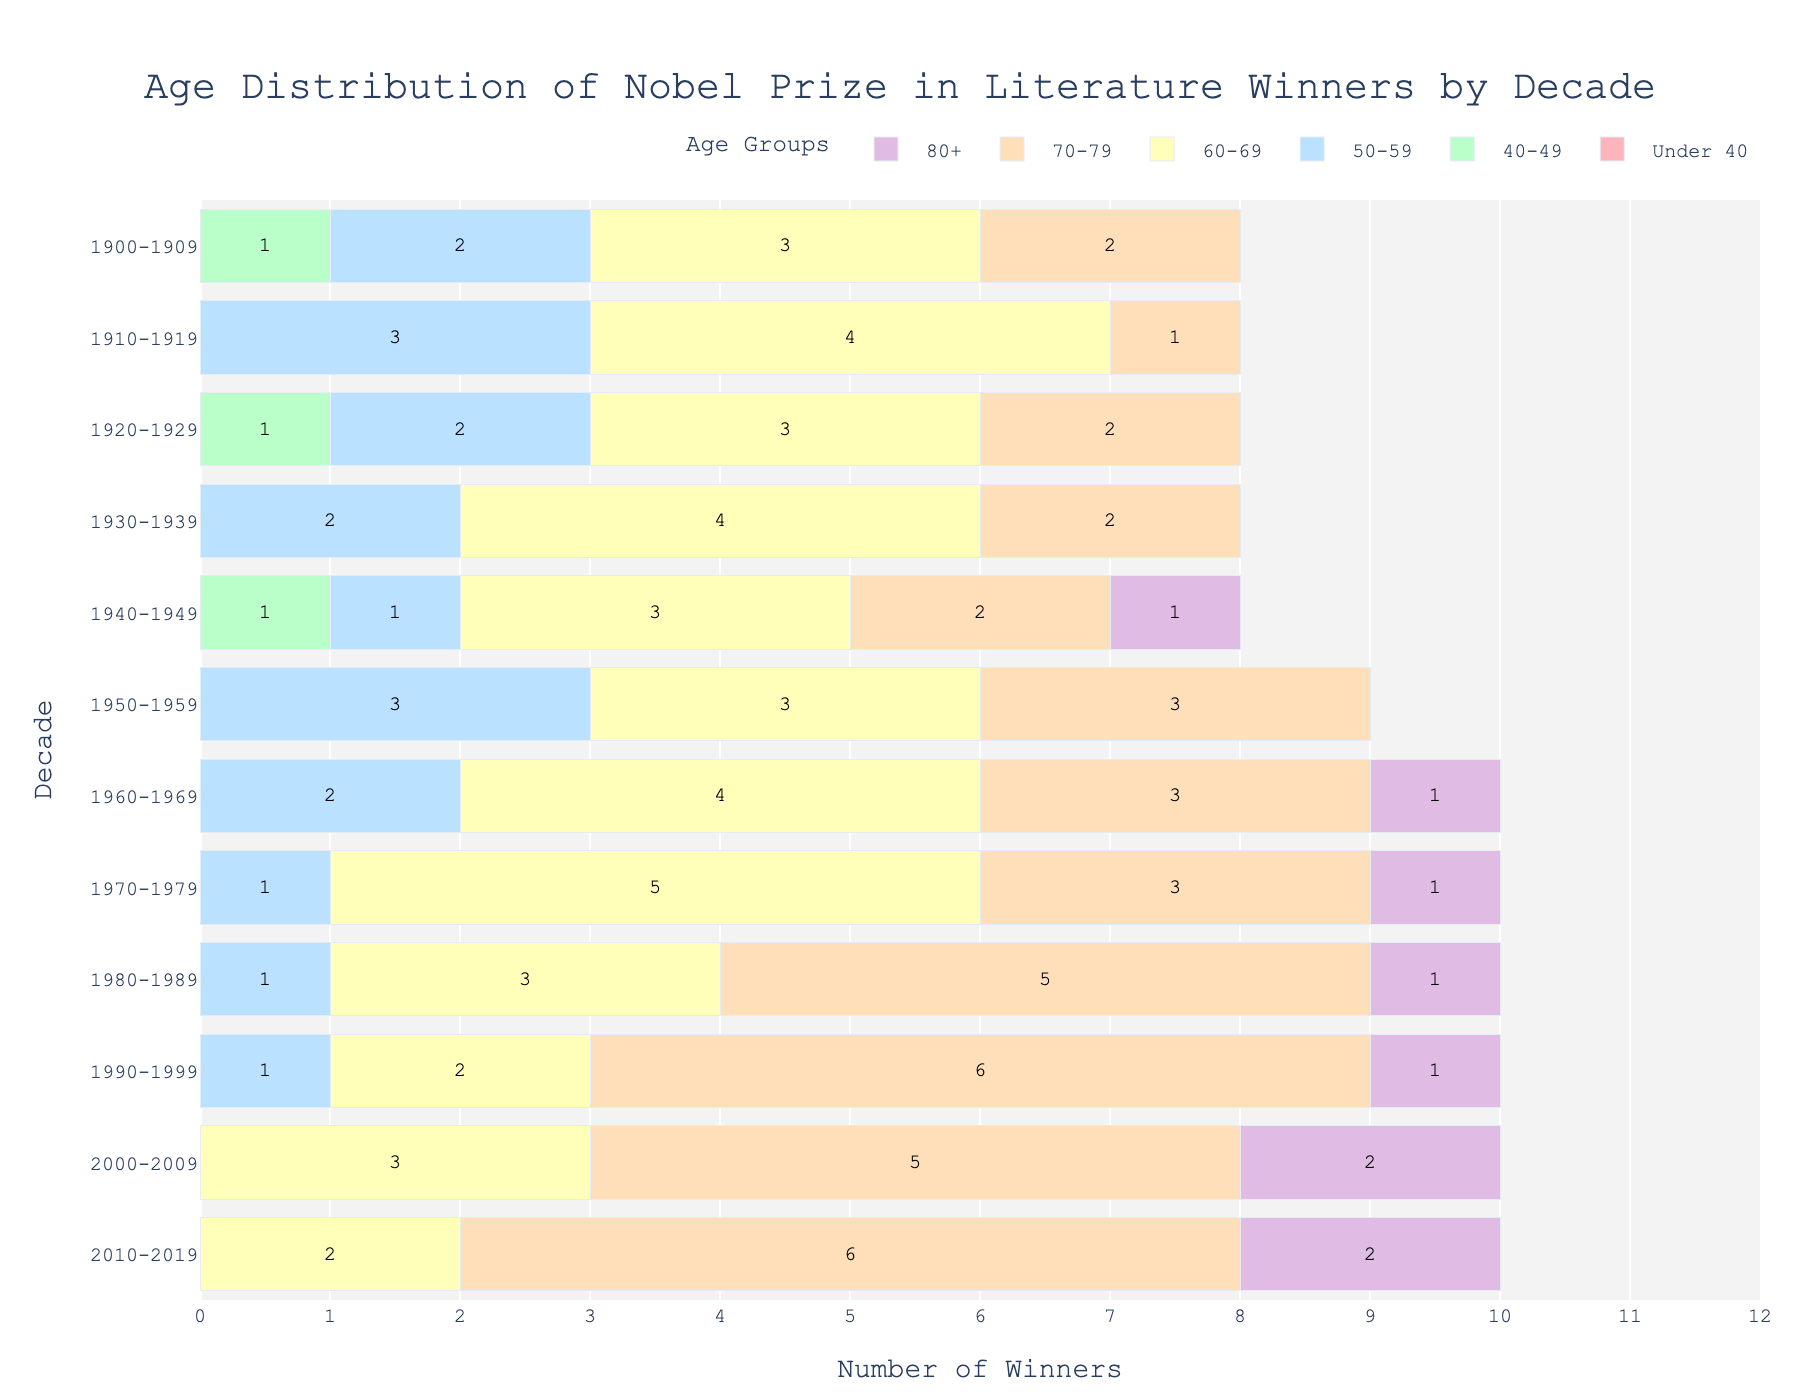How many age groups are represented in the population pyramid? There are six age groups represented in the figure. These are under 40, 40-49, 50-59, 60-69, 70-79, and 80+.
Answer: Six What is the title of the figure? The title of the figure is "Age Distribution of Nobel Prize in Literature Winners by Decade".
Answer: Age Distribution of Nobel Prize in Literature Winners by Decade In which decade did the highest number of winners aged 70-79 receive the Nobel Prize? Look at the bars colored in yellow (representing age 70-79) and find the one with the highest value. The decade is 1990-1999.
Answer: 1990-1999 How many winners in total were in the age group 60-69 during the 1900-1909 decade? Look at the bar corresponding to the 60-69 age group in the 1900-1909 decade, there are 3 winners.
Answer: 3 Which decade had the most winners aged under 40? Check the bars for the under-40 age group across all decades. None of the bars have any winners, so none of the decades had winners aged under 40.
Answer: None How many total winners were there in the 2010-2019 decade? Sum the number of winners across all age groups for the 2010-2019 decade: 0+0+0+2+6+2 = 10.
Answer: 10 In which decade did the age group 80+ first appear? Look at the bars for the age group 80+ across the decades and find the first one with a value, which is during 1940-1949.
Answer: 1940-1949 How does the number of winners aged 50-59 compare between 1910-1919 and 2000-2009? The number of winners aged 50-59 in 1910-1919 is 3, and in 2000-2009, it is 0. So, there were more winners aged 50-59 in 1910-1919 compared to 2000-2009.
Answer: More in 1910-1919 In which decade did the greatest number of winners aged 80+ receive the Nobel Prize? Look at the bars for the age group 80+ and find the one with the highest value. The decade with the most winners aged 80+ is 2000-2009 and 2010-2019, each with 2 winners.
Answer: 2000-2009 and 2010-2019 